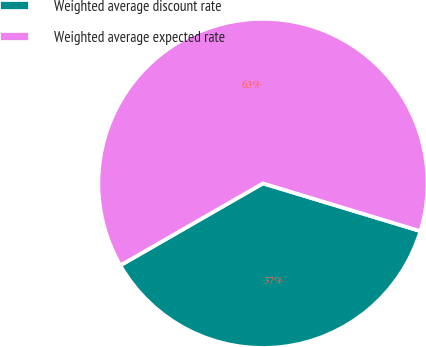Convert chart to OTSL. <chart><loc_0><loc_0><loc_500><loc_500><pie_chart><fcel>Weighted average discount rate<fcel>Weighted average expected rate<nl><fcel>37.01%<fcel>62.99%<nl></chart> 